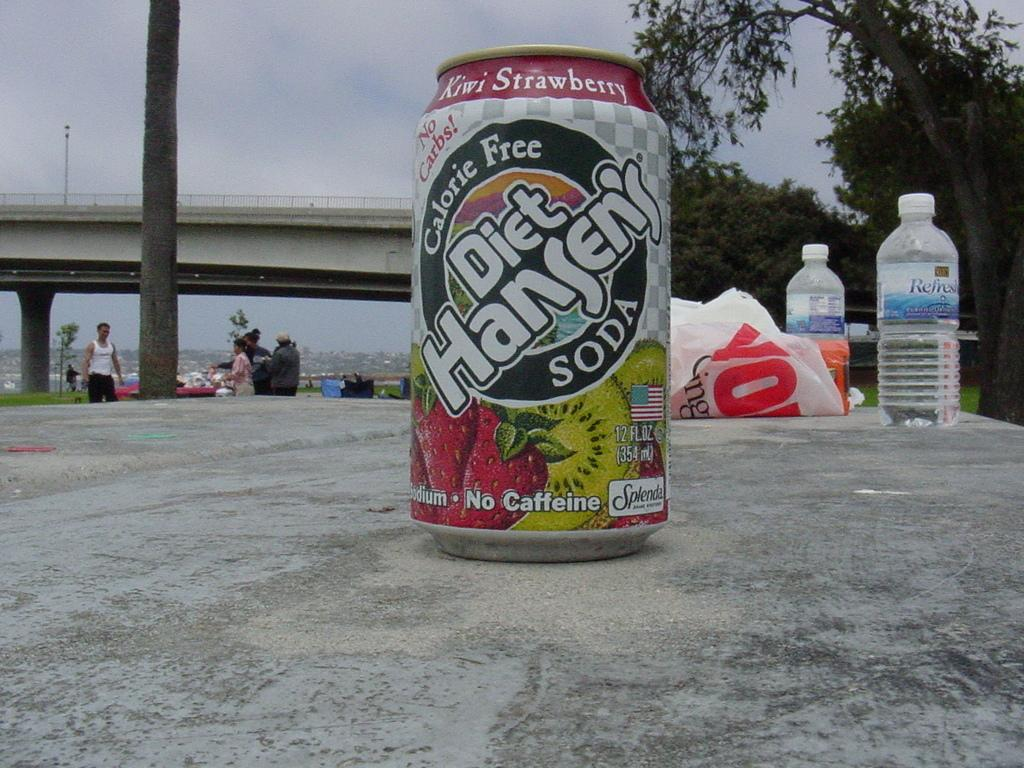<image>
Share a concise interpretation of the image provided. A can of Diet Hansen's soda says that it is calorie free. 